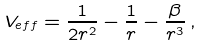<formula> <loc_0><loc_0><loc_500><loc_500>V _ { e f f } = \frac { 1 } { 2 r ^ { 2 } } - \frac { 1 } { r } - \frac { \beta } { r ^ { 3 } } \, ,</formula> 